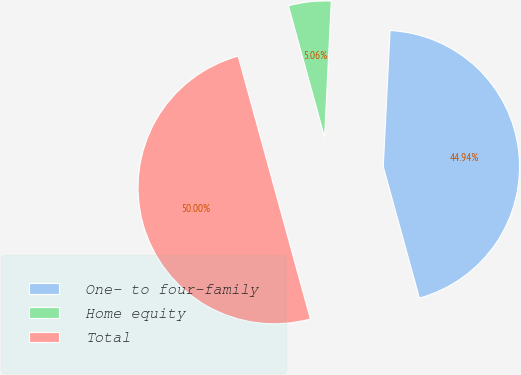<chart> <loc_0><loc_0><loc_500><loc_500><pie_chart><fcel>One- to four-family<fcel>Home equity<fcel>Total<nl><fcel>44.94%<fcel>5.06%<fcel>50.0%<nl></chart> 